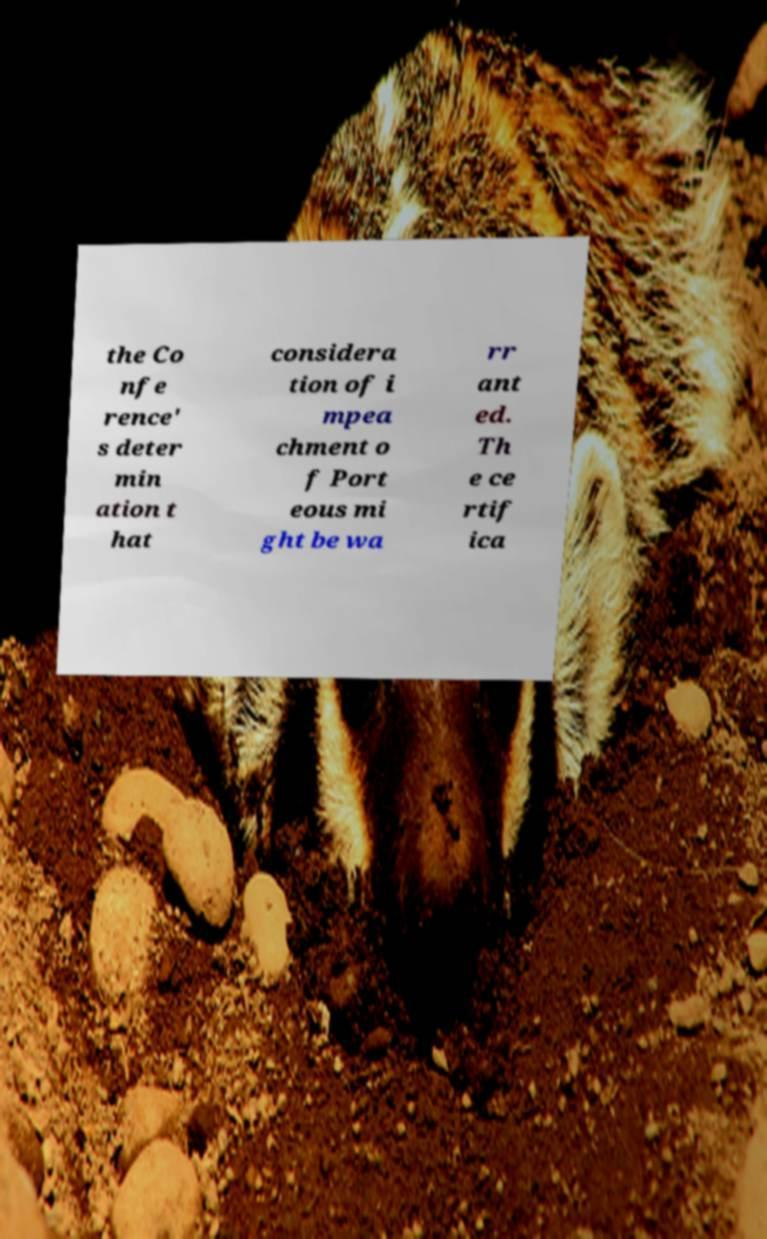Can you read and provide the text displayed in the image?This photo seems to have some interesting text. Can you extract and type it out for me? the Co nfe rence' s deter min ation t hat considera tion of i mpea chment o f Port eous mi ght be wa rr ant ed. Th e ce rtif ica 